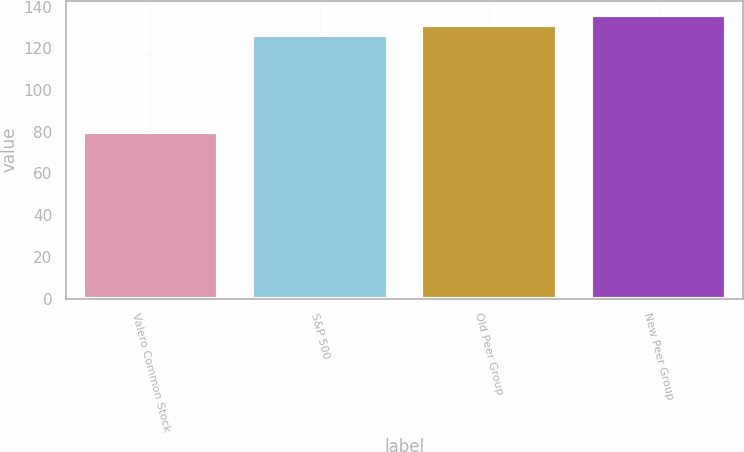<chart> <loc_0><loc_0><loc_500><loc_500><bar_chart><fcel>Valero Common Stock<fcel>S&P 500<fcel>Old Peer Group<fcel>New Peer Group<nl><fcel>79.77<fcel>126.46<fcel>131.28<fcel>136.1<nl></chart> 